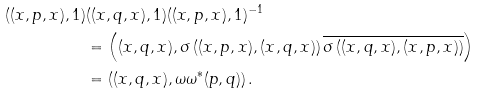Convert formula to latex. <formula><loc_0><loc_0><loc_500><loc_500>( ( x , p , x ) , 1 ) & ( ( x , q , x ) , 1 ) ( ( x , p , x ) , 1 ) ^ { - 1 } \\ & = \left ( ( x , q , x ) , \sigma \left ( ( x , p , x ) , ( x , q , x ) \right ) \overline { \sigma \left ( ( x , q , x ) , ( x , p , x ) \right ) } \right ) \\ & = \left ( ( x , q , x ) , \omega \omega ^ { * } ( p , q ) \right ) .</formula> 